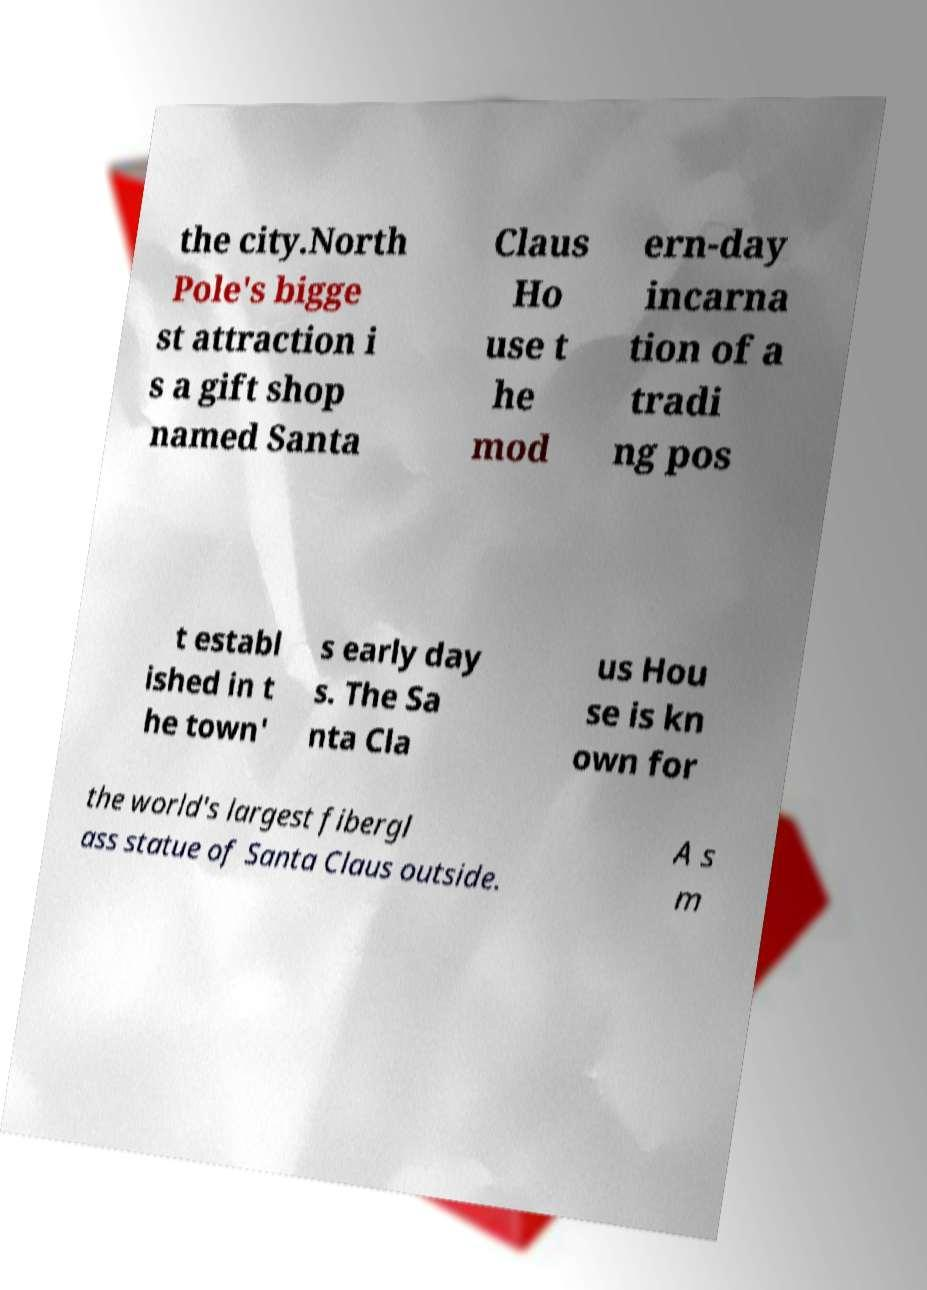Please read and relay the text visible in this image. What does it say? the city.North Pole's bigge st attraction i s a gift shop named Santa Claus Ho use t he mod ern-day incarna tion of a tradi ng pos t establ ished in t he town' s early day s. The Sa nta Cla us Hou se is kn own for the world's largest fibergl ass statue of Santa Claus outside. A s m 